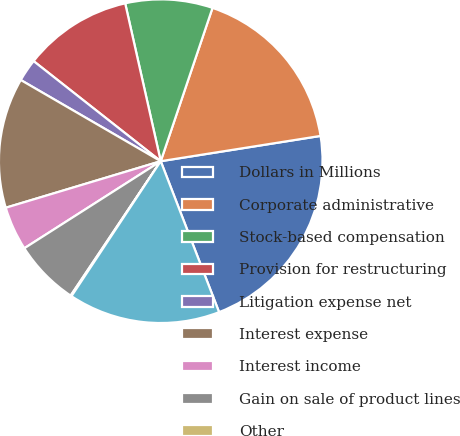<chart> <loc_0><loc_0><loc_500><loc_500><pie_chart><fcel>Dollars in Millions<fcel>Corporate administrative<fcel>Stock-based compensation<fcel>Provision for restructuring<fcel>Litigation expense net<fcel>Interest expense<fcel>Interest income<fcel>Gain on sale of product lines<fcel>Other<fcel>Total Corporate/Other earnings<nl><fcel>21.63%<fcel>17.32%<fcel>8.71%<fcel>10.86%<fcel>2.25%<fcel>13.01%<fcel>4.4%<fcel>6.56%<fcel>0.1%<fcel>15.17%<nl></chart> 